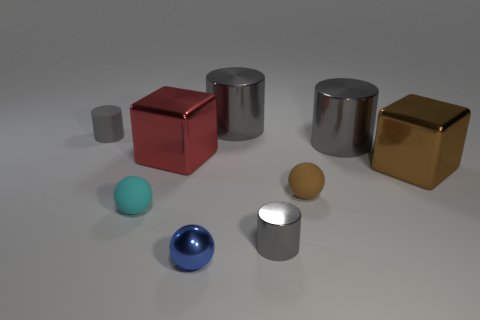The other matte object that is the same shape as the tiny brown thing is what size?
Your response must be concise. Small. How many other objects are the same size as the red block?
Your answer should be very brief. 3. There is a rubber thing that is the same color as the tiny metallic cylinder; what is its size?
Keep it short and to the point. Small. What number of spheres are small cyan objects or large gray objects?
Provide a succinct answer. 1. Is the shape of the tiny blue shiny object that is in front of the small cyan rubber object the same as  the small cyan thing?
Provide a succinct answer. Yes. Are there more tiny cylinders that are behind the large brown cube than big green balls?
Provide a short and direct response. Yes. The other matte sphere that is the same size as the cyan ball is what color?
Your answer should be very brief. Brown. What number of objects are either tiny matte things that are left of the blue metal thing or cyan matte things?
Your answer should be very brief. 2. What is the shape of the rubber thing that is the same color as the small shiny cylinder?
Ensure brevity in your answer.  Cylinder. The brown object that is on the left side of the big metallic cylinder right of the tiny gray metal object is made of what material?
Offer a terse response. Rubber. 